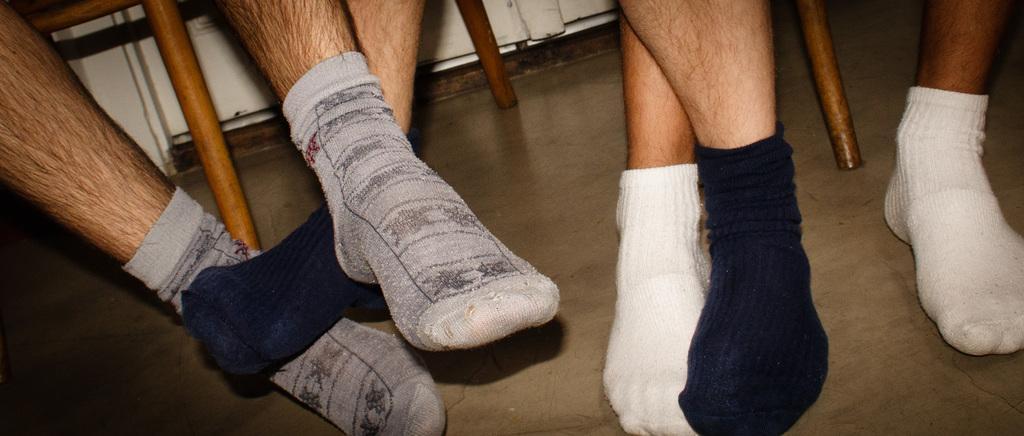How would you summarize this image in a sentence or two? In this image we can see human legs. 